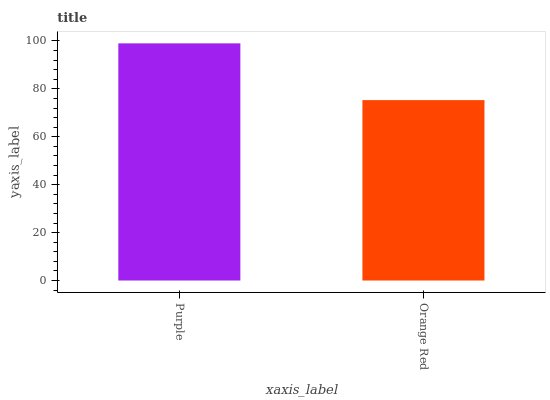Is Orange Red the maximum?
Answer yes or no. No. Is Purple greater than Orange Red?
Answer yes or no. Yes. Is Orange Red less than Purple?
Answer yes or no. Yes. Is Orange Red greater than Purple?
Answer yes or no. No. Is Purple less than Orange Red?
Answer yes or no. No. Is Purple the high median?
Answer yes or no. Yes. Is Orange Red the low median?
Answer yes or no. Yes. Is Orange Red the high median?
Answer yes or no. No. Is Purple the low median?
Answer yes or no. No. 